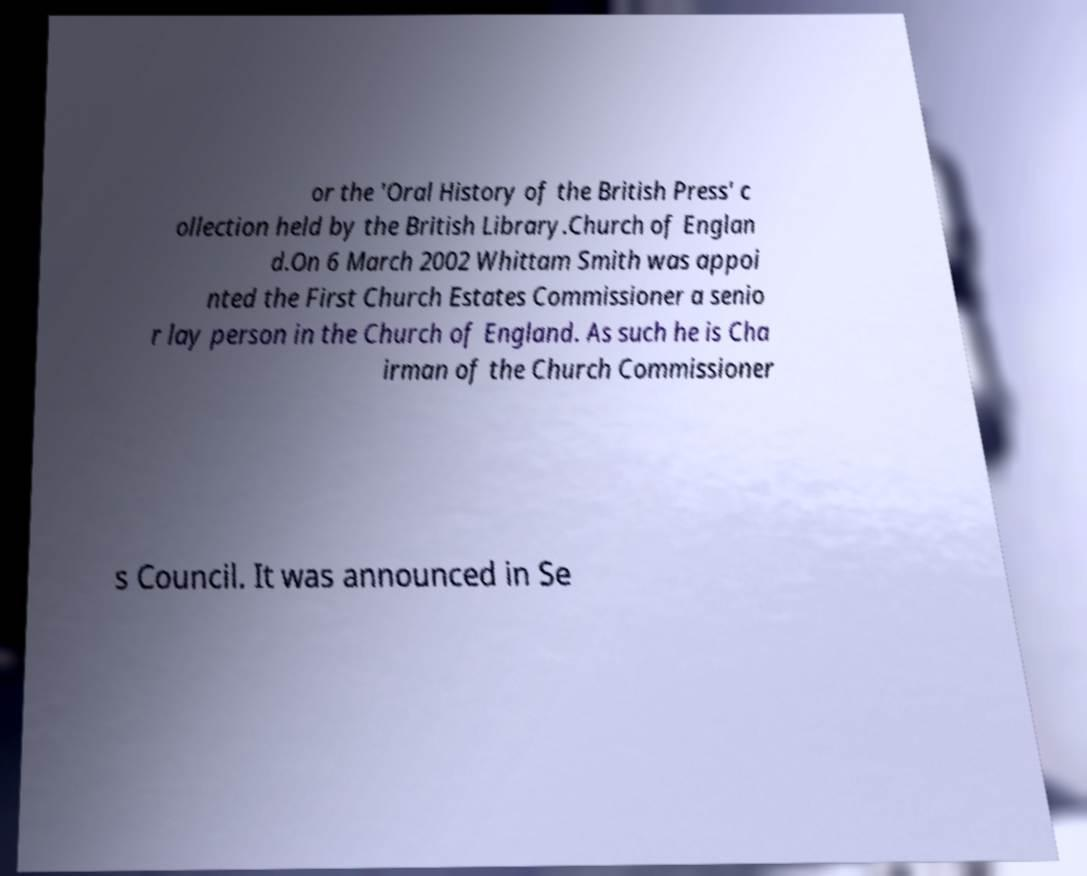Could you extract and type out the text from this image? or the 'Oral History of the British Press' c ollection held by the British Library.Church of Englan d.On 6 March 2002 Whittam Smith was appoi nted the First Church Estates Commissioner a senio r lay person in the Church of England. As such he is Cha irman of the Church Commissioner s Council. It was announced in Se 